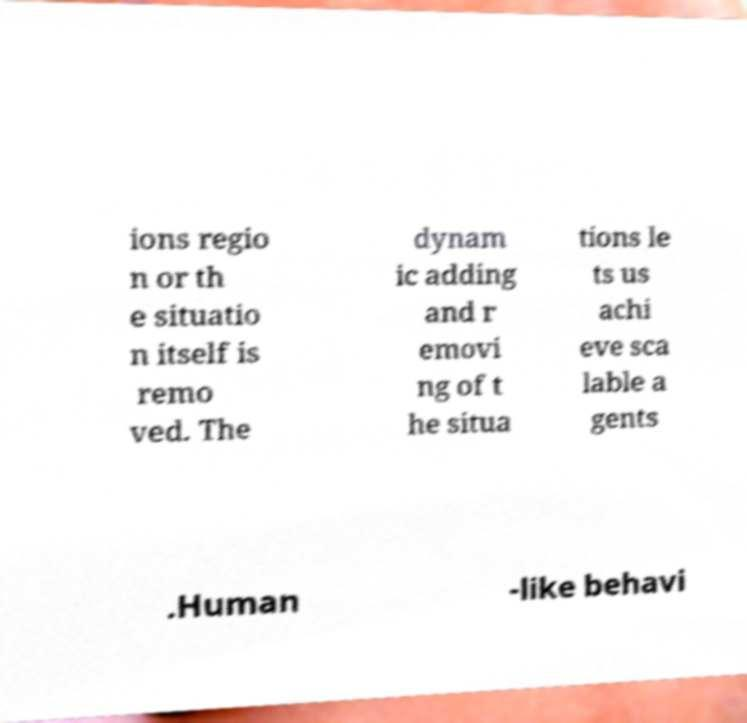There's text embedded in this image that I need extracted. Can you transcribe it verbatim? ions regio n or th e situatio n itself is remo ved. The dynam ic adding and r emovi ng of t he situa tions le ts us achi eve sca lable a gents .Human -like behavi 